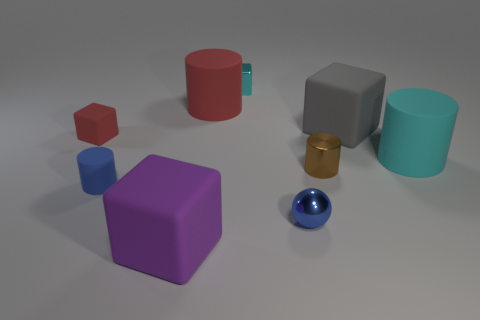Subtract all tiny matte blocks. How many blocks are left? 3 Subtract all gray blocks. How many blocks are left? 3 Add 1 large brown rubber cylinders. How many objects exist? 10 Subtract all spheres. How many objects are left? 8 Subtract 3 blocks. How many blocks are left? 1 Subtract all cyan rubber cubes. Subtract all small blue balls. How many objects are left? 8 Add 8 tiny metallic cylinders. How many tiny metallic cylinders are left? 9 Add 5 cyan shiny blocks. How many cyan shiny blocks exist? 6 Subtract 1 gray cubes. How many objects are left? 8 Subtract all brown cubes. Subtract all cyan cylinders. How many cubes are left? 4 